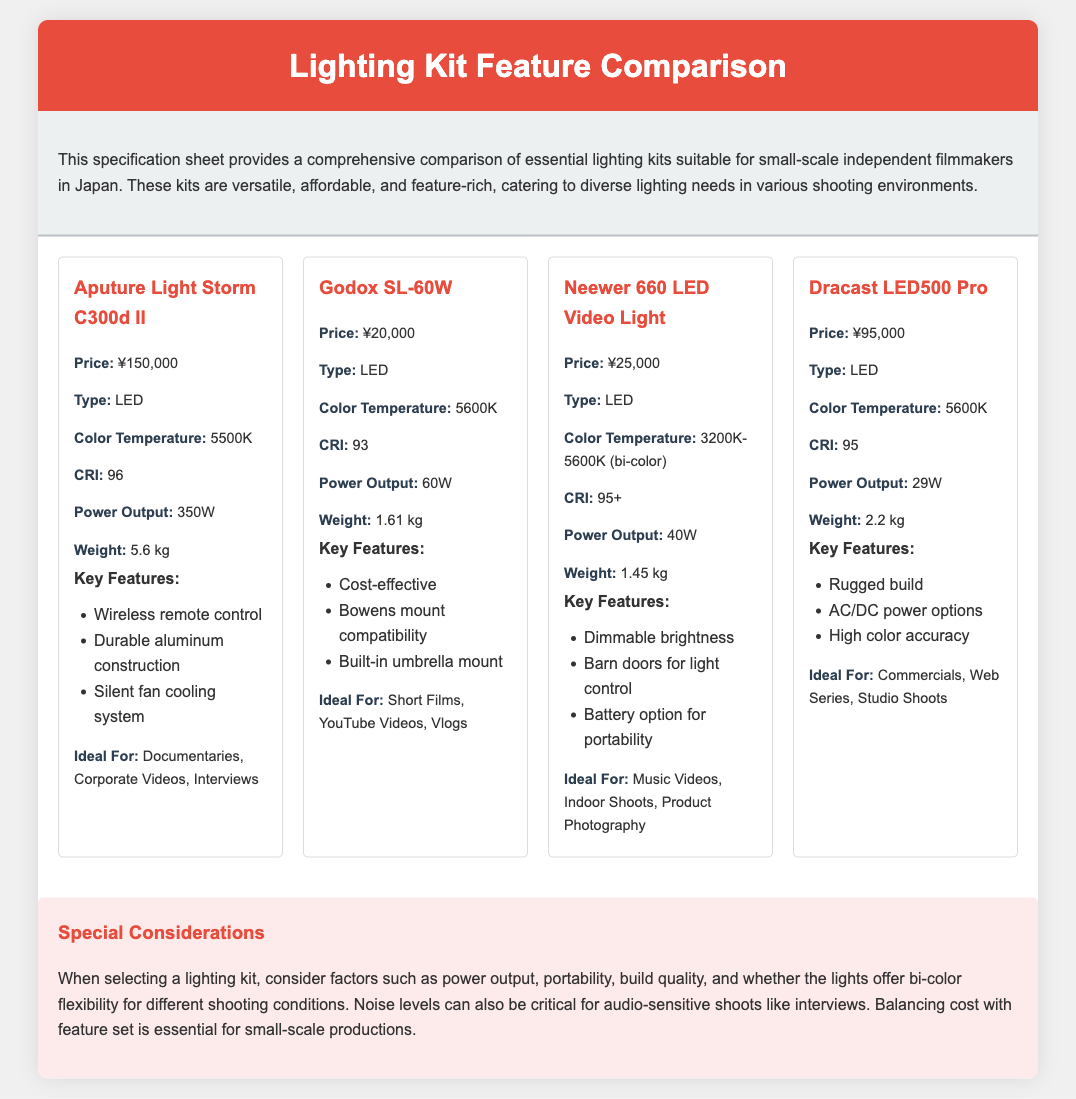What is the price of Aputure Light Storm C300d II? The price of Aputure Light Storm C300d II is mentioned in the document as ¥150,000.
Answer: ¥150,000 What type of light is Godox SL-60W? The document specifies that Godox SL-60W is an LED light.
Answer: LED What is the CRI of Neewer 660 LED Video Light? The CRI of Neewer 660 LED Video Light is provided in the document as 95+.
Answer: 95+ Which lighting kit is ideal for documentaries? The document indicates that Aputure Light Storm C300d II is ideal for documentaries.
Answer: Aputure Light Storm C300d II What is the power output of Dracast LED500 Pro? The power output for Dracast LED500 Pro is stated in the document as 29W.
Answer: 29W Which kit is the most cost-effective? The document highlights Godox SL-60W as a cost-effective option among the kits.
Answer: Godox SL-60W What color temperature range does Neewer 660 LED Video Light offer? The document describes the color temperature range of Neewer 660 LED Video Light as 3200K-5600K (bi-color).
Answer: 3200K-5600K (bi-color) What key feature does the Aputure Light Storm C300d II have? The document lists "Wireless remote control" as a key feature of Aputure Light Storm C300d II.
Answer: Wireless remote control What special consideration is mentioned for selecting a lighting kit? The document notes that noise levels can be critical for audio-sensitive shoots like interviews as a special consideration.
Answer: Noise levels 